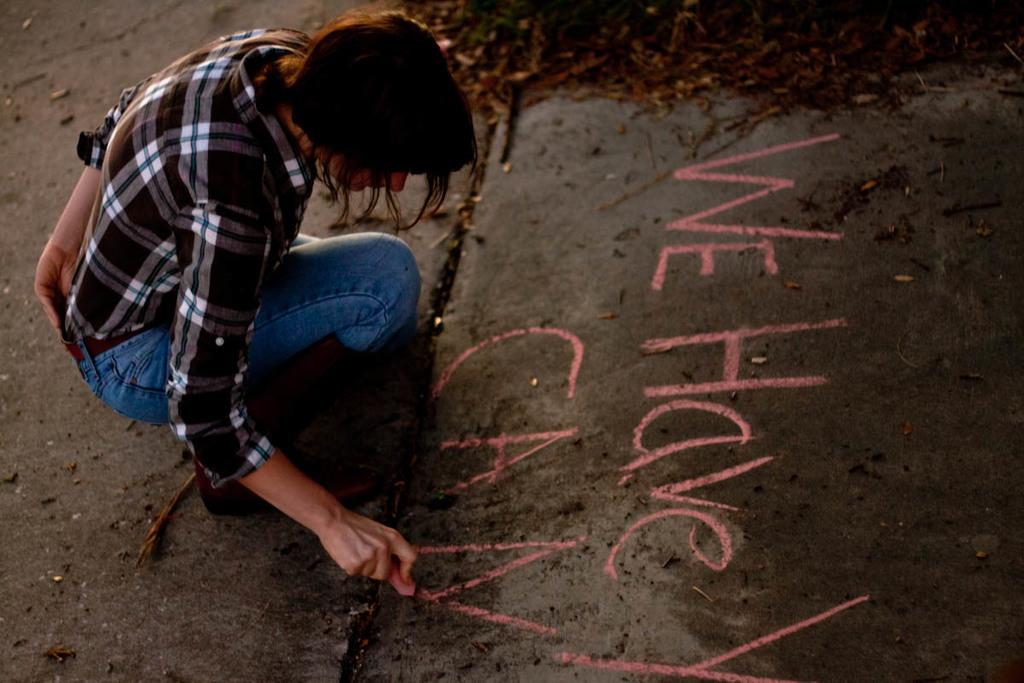Who is the main subject in the image? There is a woman in the image. What is the woman doing in the image? The woman is writing something on the ground. What color is the chalk the woman is using? The woman is using pink chalk. What can be seen in the background of the image? There are small sticks and leaves in the background of the image. Is the woman's uncle crying in the image? There is no uncle or crying person present in the image. Can you see a railway in the background of the image? There is no railway visible in the image; only small sticks and leaves can be seen in the background. 